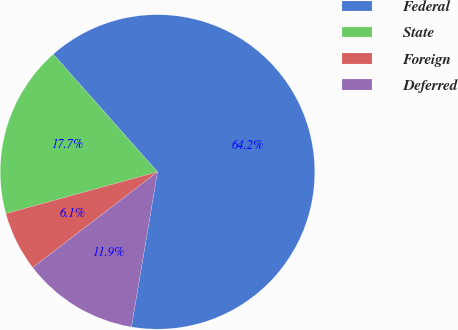Convert chart to OTSL. <chart><loc_0><loc_0><loc_500><loc_500><pie_chart><fcel>Federal<fcel>State<fcel>Foreign<fcel>Deferred<nl><fcel>64.18%<fcel>17.74%<fcel>6.13%<fcel>11.94%<nl></chart> 